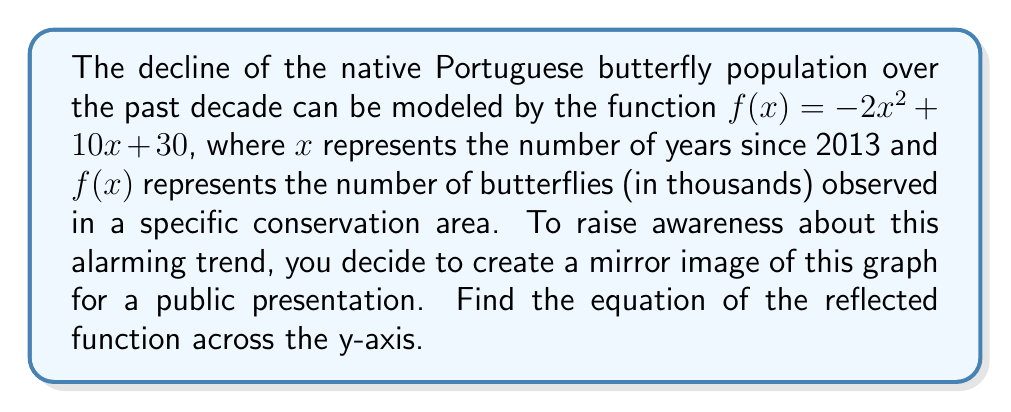Teach me how to tackle this problem. To reflect a function across the y-axis, we replace every $x$ with $-x$ in the original function. This process can be broken down into steps:

1. Start with the original function: $f(x) = -2x^2 + 10x + 30$

2. Replace every $x$ with $-x$:
   $f(-x) = -2(-x)^2 + 10(-x) + 30$

3. Simplify:
   $f(-x) = -2x^2 - 10x + 30$

4. The resulting function $f(-x)$ is the reflection of $f(x)$ across the y-axis.

5. To maintain the standard form, we can rename this reflected function as $g(x)$:
   $g(x) = -2x^2 - 10x + 30$

This new function $g(x)$ represents the mirror image of the original butterfly population decline graph across the y-axis.
Answer: $g(x) = -2x^2 - 10x + 30$ 